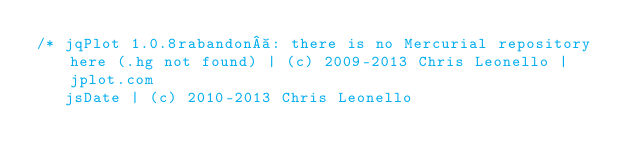Convert code to text. <code><loc_0><loc_0><loc_500><loc_500><_JavaScript_>/* jqPlot 1.0.8rabandon : there is no Mercurial repository here (.hg not found) | (c) 2009-2013 Chris Leonello | jplot.com
   jsDate | (c) 2010-2013 Chris Leonello</code> 